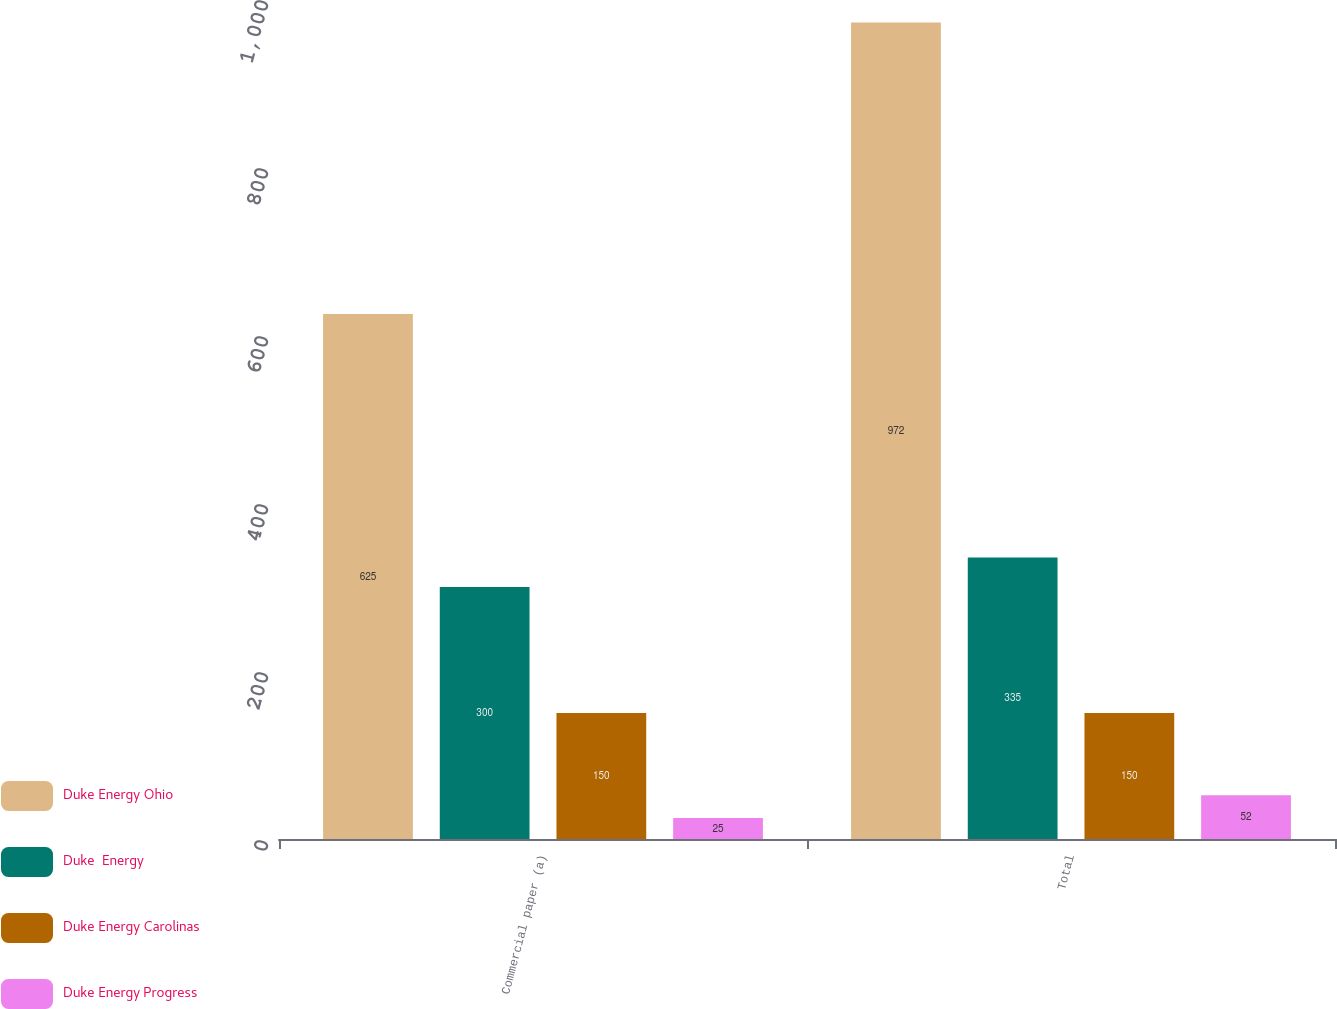Convert chart to OTSL. <chart><loc_0><loc_0><loc_500><loc_500><stacked_bar_chart><ecel><fcel>Commercial paper (a)<fcel>Total<nl><fcel>Duke Energy Ohio<fcel>625<fcel>972<nl><fcel>Duke  Energy<fcel>300<fcel>335<nl><fcel>Duke Energy Carolinas<fcel>150<fcel>150<nl><fcel>Duke Energy Progress<fcel>25<fcel>52<nl></chart> 